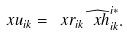<formula> <loc_0><loc_0><loc_500><loc_500>\ x u _ { i k } = \ x r _ { i k } { \widehat { \ x h } } _ { i k } ^ { i \ast } .</formula> 